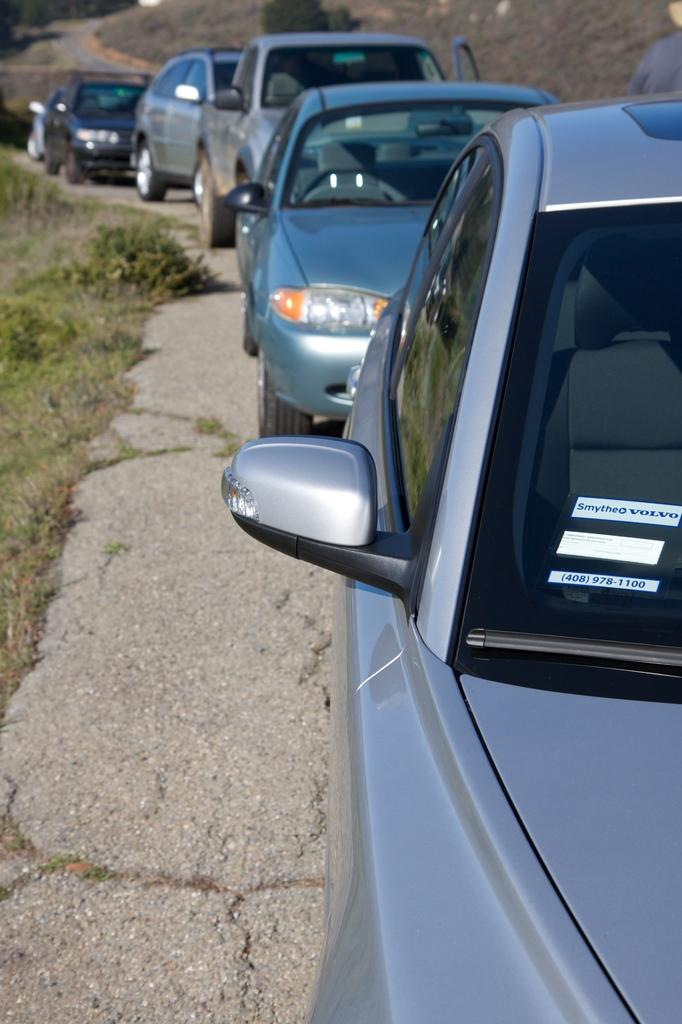What is the main feature of the image? There is a road in the image. What can be seen on the road? There are cars on the road. What type of vegetation is on the left side of the image? There is grass on the left side of the image. What is visible in the background of the image? There is a hill in the background of the image. What type of apple can be seen playing a rhythm on its toe in the image? There is no apple or any indication of rhythm or toes in the image. 